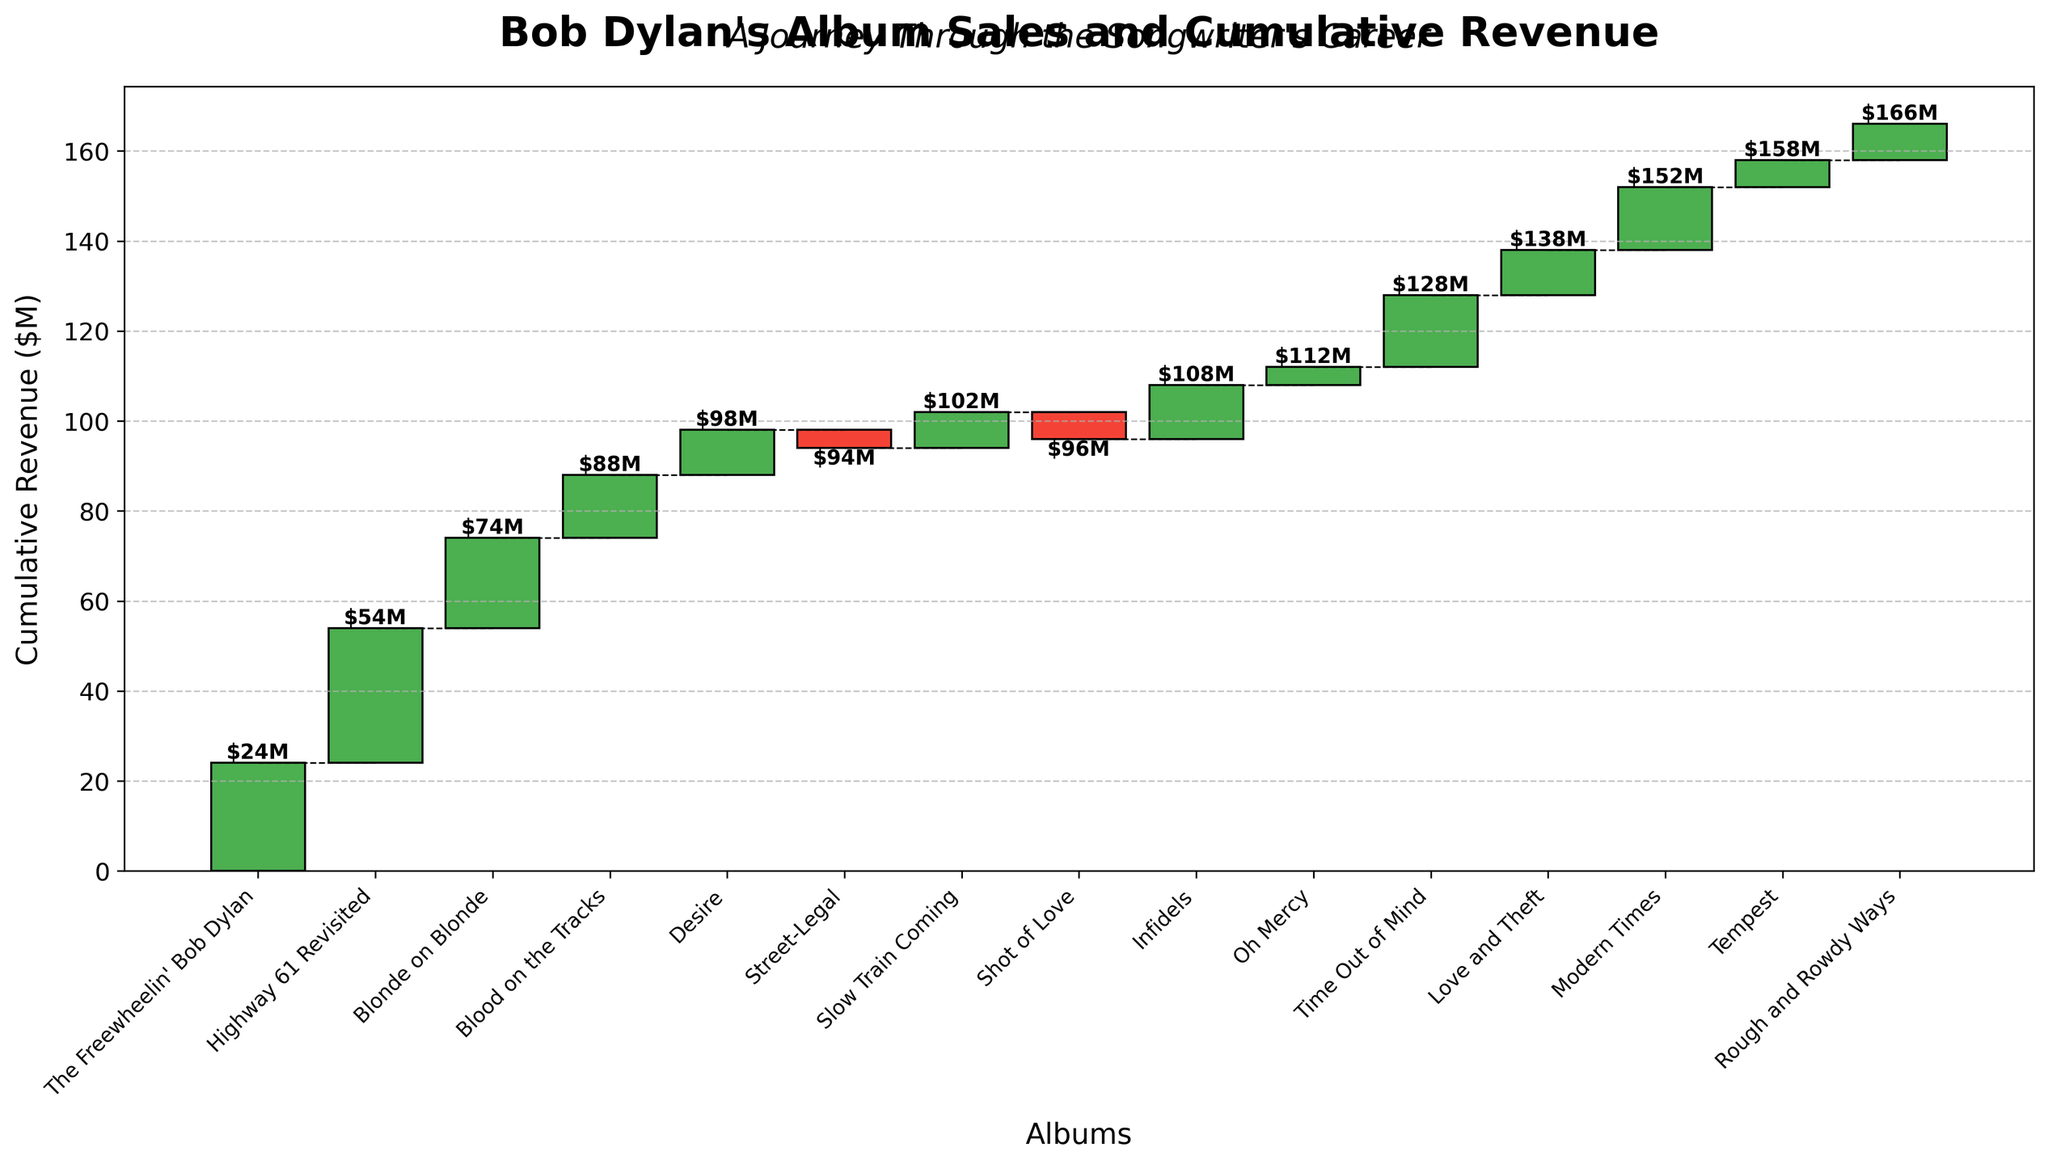What is the title of the chart? The title is displayed at the top of the chart and reads "Bob Dylan's Album Sales and Cumulative Revenue".
Answer: Bob Dylan's Album Sales and Cumulative Revenue How does the chart subtitle describe the plot? The subtitle directly below the title reads "A Journey Through the Songwriter's Career".
Answer: A Journey Through the Songwriter's Career How many albums are represented in the chart? To find the number of albums, count the x-axis labels, which correspond to each bar in the chart. There are 15 albums listed.
Answer: 15 Which album experienced a negative change in revenue, and how much was the change? Identify bars colored red (negative values). "Street-Legal" and "Shot of Love" experienced negative changes, with "Street-Legal" having a -4 million dollars and "Shot of Love" having -6 million dollars contribution to cumulative revenue.
Answer: Street-Legal, -4 million dollars; Shot of Love, -6 million dollars What is the cumulative revenue after the release of "Desire"? Locate the bar for "Desire" and find the value labeled at the top of the bar. It is 98 million dollars.
Answer: 98 million dollars Which album had the highest increase in cumulative revenue and by how much? Identify the tallest green bar, which indicates the highest positive difference. "Highway 61 Revisited" has the highest increase of 30 million dollars (from 24 to 54 million).
Answer: Highway 61 Revisited, 30 million dollars Are there more albums with positive or negative changes in revenue? Count the number of green bars (positive changes) and red bars (negative changes). There are 13 positive changes and 2 negative changes.
Answer: More positive changes What is the cumulative revenue at the end of the chart, after "Rough and Rowdy Ways"? Locate the final bar corresponding to "Rough and Rowdy Ways" and find the value at the top of the bar. It is 166 million dollars.
Answer: 166 million dollars Between which two albums did Bob Dylan see a decrease in cumulative revenue? Identify gaps between album bars connected by dotted lines that drop to a lower value. The decrease occurs between "Street-Legal" to "Slow Train Coming" and "Shot of Love" to "Infidels".
Answer: Street-Legal to Slow Train Coming, Shot of Love to Infidels What is the total cumulative revenue increase from "The Freewheelin' Bob Dylan" to "Modern Times"? Sum the increases for each album up to "Modern Times" and find the resulting cumulative revenue for "Modern Times", which is 152 million dollars. Calculate the total increase from the initial value (24 million) to the final value (152 million). Subtract the initial cumulative revenue from the cumulative revenue of "Modern Times". Thus, (152 - 24) million dollars.
Answer: 128 million dollars 